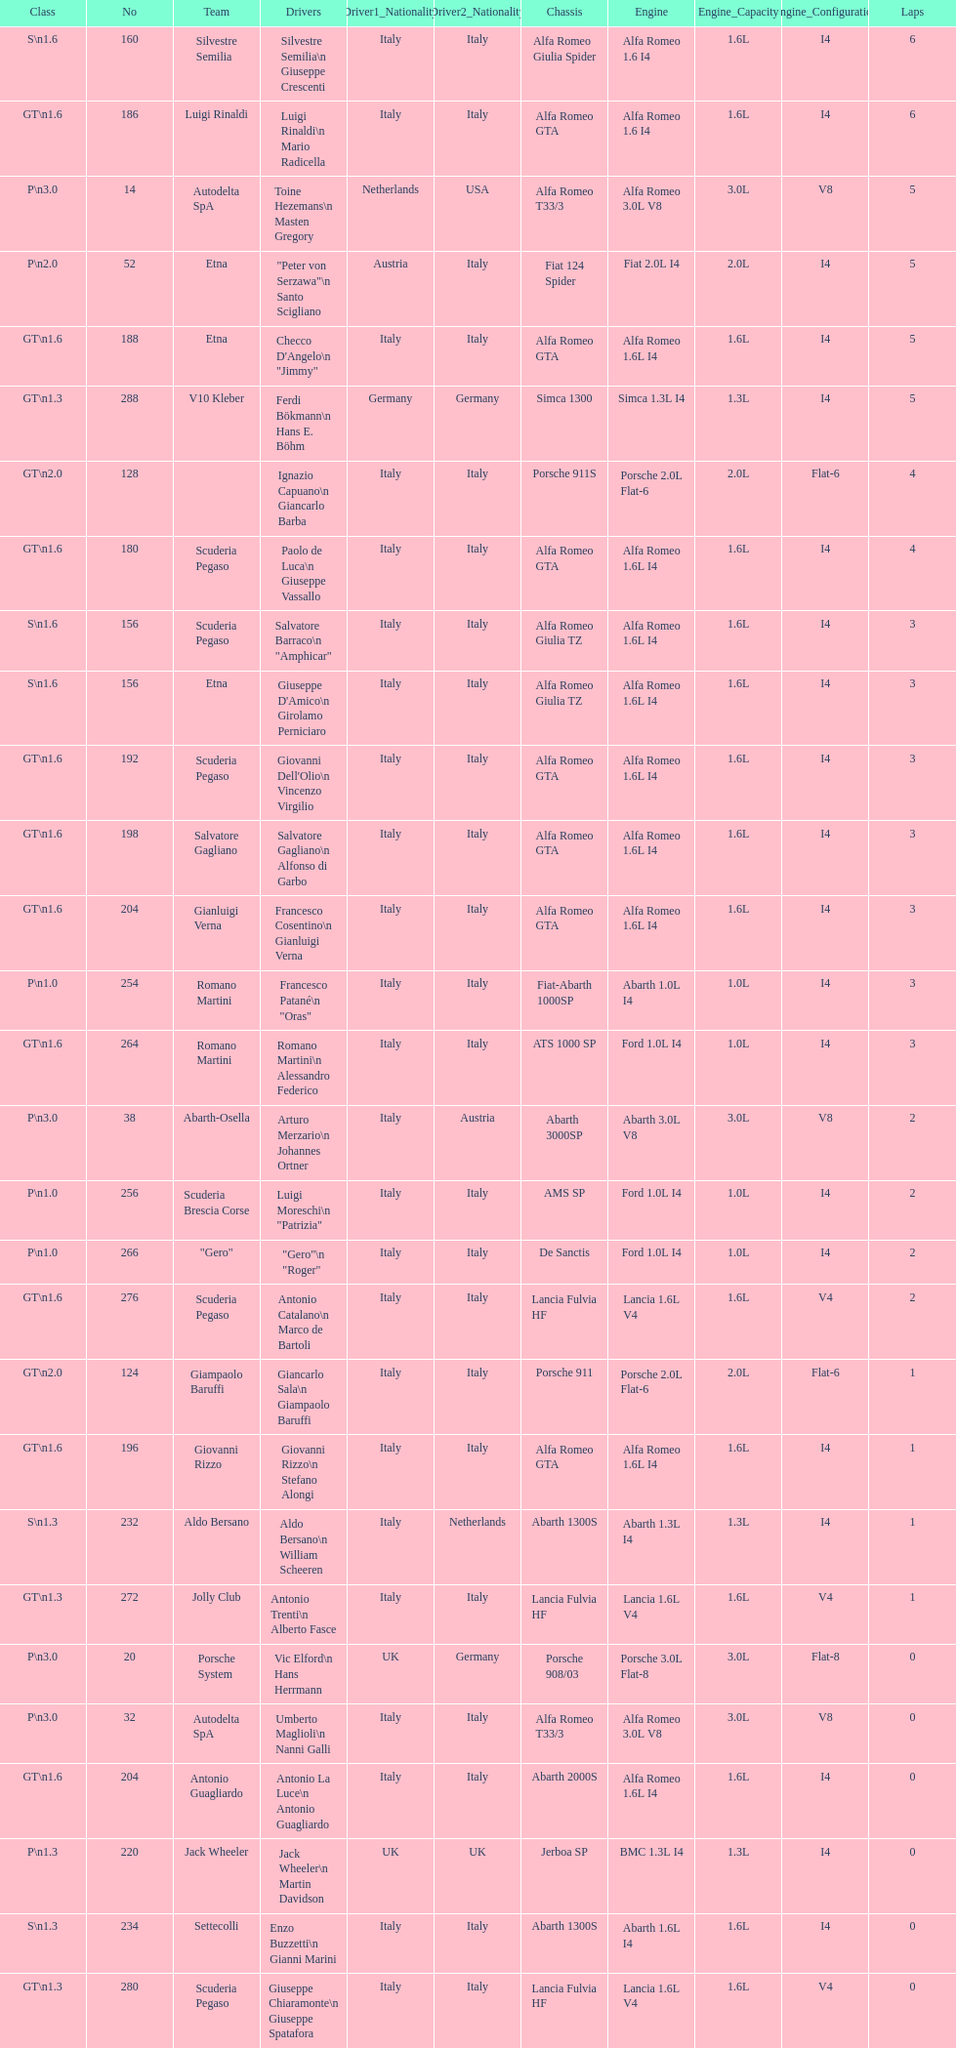Name the only american who did not finish the race. Masten Gregory. 